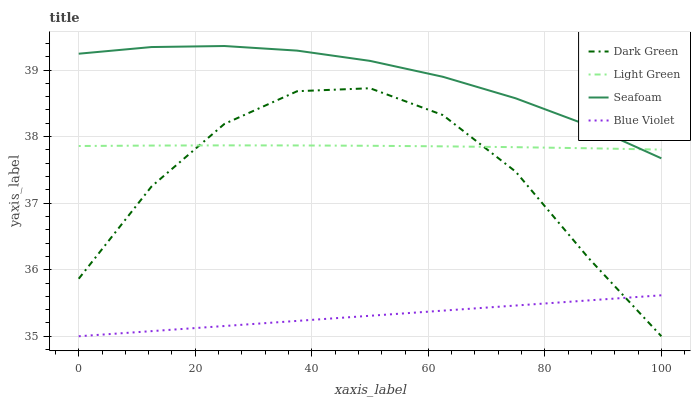Does Blue Violet have the minimum area under the curve?
Answer yes or no. Yes. Does Seafoam have the maximum area under the curve?
Answer yes or no. Yes. Does Light Green have the minimum area under the curve?
Answer yes or no. No. Does Light Green have the maximum area under the curve?
Answer yes or no. No. Is Blue Violet the smoothest?
Answer yes or no. Yes. Is Dark Green the roughest?
Answer yes or no. Yes. Is Seafoam the smoothest?
Answer yes or no. No. Is Seafoam the roughest?
Answer yes or no. No. Does Blue Violet have the lowest value?
Answer yes or no. Yes. Does Seafoam have the lowest value?
Answer yes or no. No. Does Seafoam have the highest value?
Answer yes or no. Yes. Does Light Green have the highest value?
Answer yes or no. No. Is Blue Violet less than Light Green?
Answer yes or no. Yes. Is Seafoam greater than Dark Green?
Answer yes or no. Yes. Does Dark Green intersect Blue Violet?
Answer yes or no. Yes. Is Dark Green less than Blue Violet?
Answer yes or no. No. Is Dark Green greater than Blue Violet?
Answer yes or no. No. Does Blue Violet intersect Light Green?
Answer yes or no. No. 